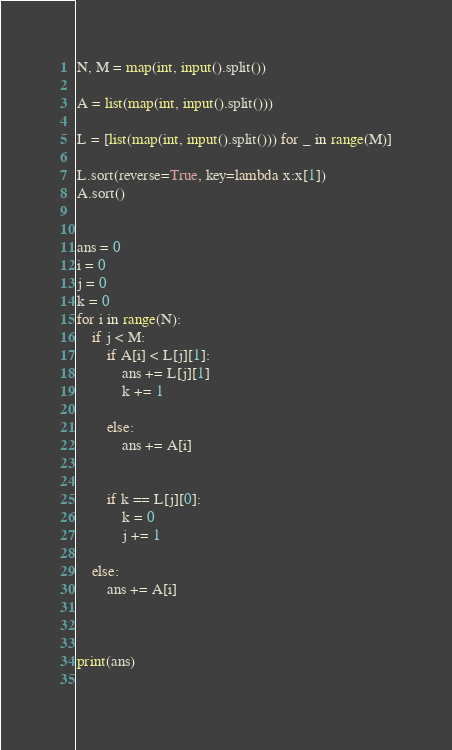Convert code to text. <code><loc_0><loc_0><loc_500><loc_500><_Python_>N, M = map(int, input().split())

A = list(map(int, input().split()))

L = [list(map(int, input().split())) for _ in range(M)]

L.sort(reverse=True, key=lambda x:x[1])
A.sort()


ans = 0
i = 0
j = 0
k = 0
for i in range(N):
    if j < M:
        if A[i] < L[j][1]:
            ans += L[j][1]
            k += 1
            
        else:
            ans += A[i]
        
        
        if k == L[j][0]:
            k = 0
            j += 1
            
    else:
        ans += A[i]
        

        
print(ans)
    </code> 